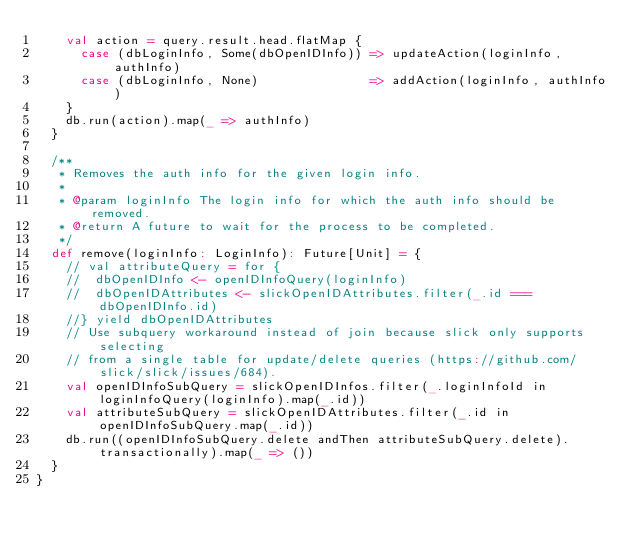Convert code to text. <code><loc_0><loc_0><loc_500><loc_500><_Scala_>    val action = query.result.head.flatMap {
      case (dbLoginInfo, Some(dbOpenIDInfo)) => updateAction(loginInfo, authInfo)
      case (dbLoginInfo, None)               => addAction(loginInfo, authInfo)
    }
    db.run(action).map(_ => authInfo)
  }

  /**
   * Removes the auth info for the given login info.
   *
   * @param loginInfo The login info for which the auth info should be removed.
   * @return A future to wait for the process to be completed.
   */
  def remove(loginInfo: LoginInfo): Future[Unit] = {
    // val attributeQuery = for {
    //  dbOpenIDInfo <- openIDInfoQuery(loginInfo)
    //  dbOpenIDAttributes <- slickOpenIDAttributes.filter(_.id === dbOpenIDInfo.id)
    //} yield dbOpenIDAttributes
    // Use subquery workaround instead of join because slick only supports selecting
    // from a single table for update/delete queries (https://github.com/slick/slick/issues/684).
    val openIDInfoSubQuery = slickOpenIDInfos.filter(_.loginInfoId in loginInfoQuery(loginInfo).map(_.id))
    val attributeSubQuery = slickOpenIDAttributes.filter(_.id in openIDInfoSubQuery.map(_.id))
    db.run((openIDInfoSubQuery.delete andThen attributeSubQuery.delete).transactionally).map(_ => ())
  }
}
</code> 